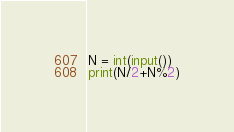Convert code to text. <code><loc_0><loc_0><loc_500><loc_500><_Python_>N = int(input())
print(N/2+N%2)</code> 